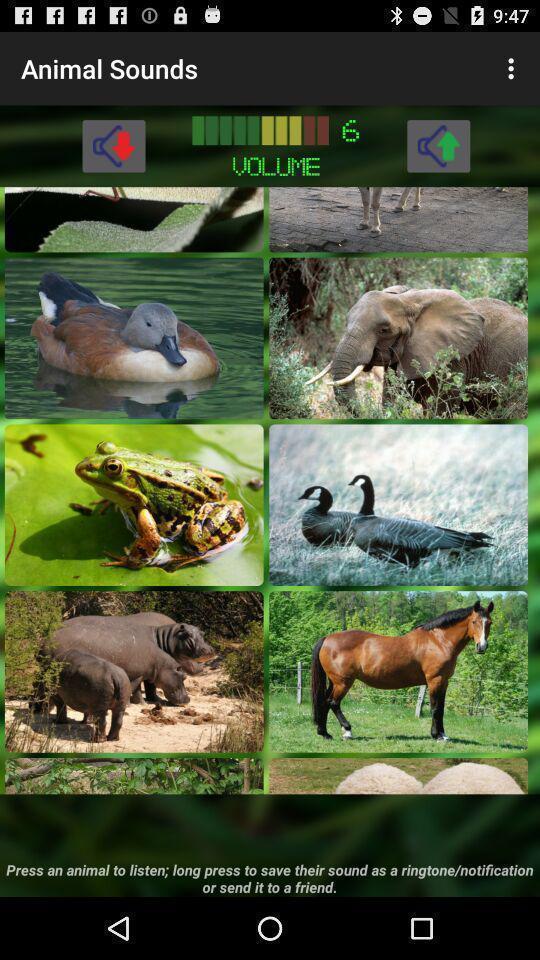Describe the visual elements of this screenshot. Page displaying list of animal images in the app. 